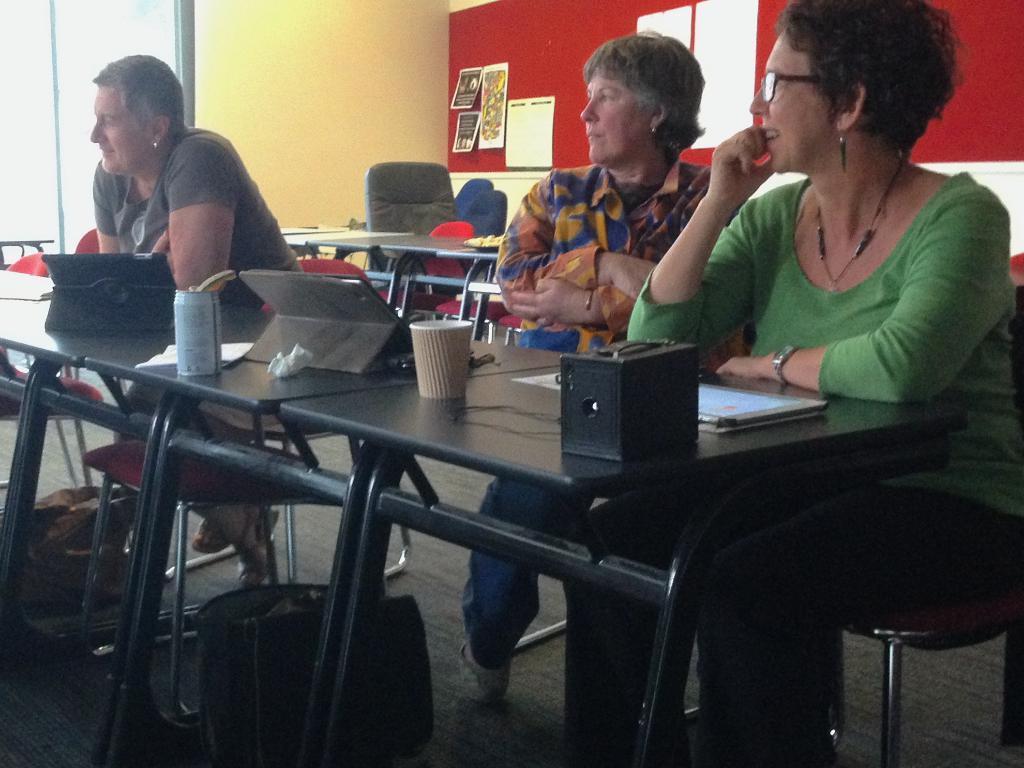Describe this image in one or two sentences. Here we can see three people sitting on chairs with table in front of them having books tablets and a cup and a tin present on it and behind them we can see table and chairs present and on the wall we can see posters present 